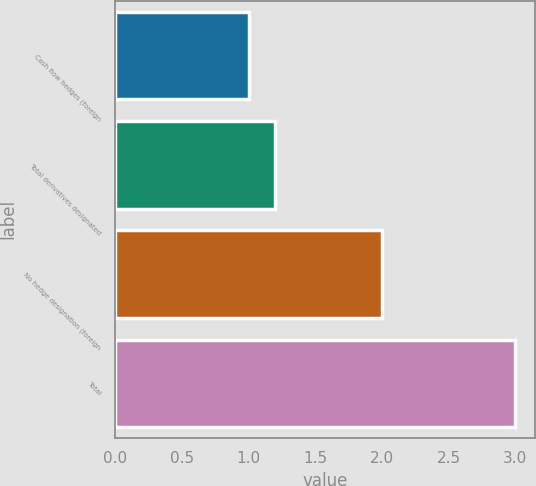Convert chart. <chart><loc_0><loc_0><loc_500><loc_500><bar_chart><fcel>Cash flow hedges (foreign<fcel>Total derivatives designated<fcel>No hedge designation (foreign<fcel>Total<nl><fcel>1<fcel>1.2<fcel>2<fcel>3<nl></chart> 